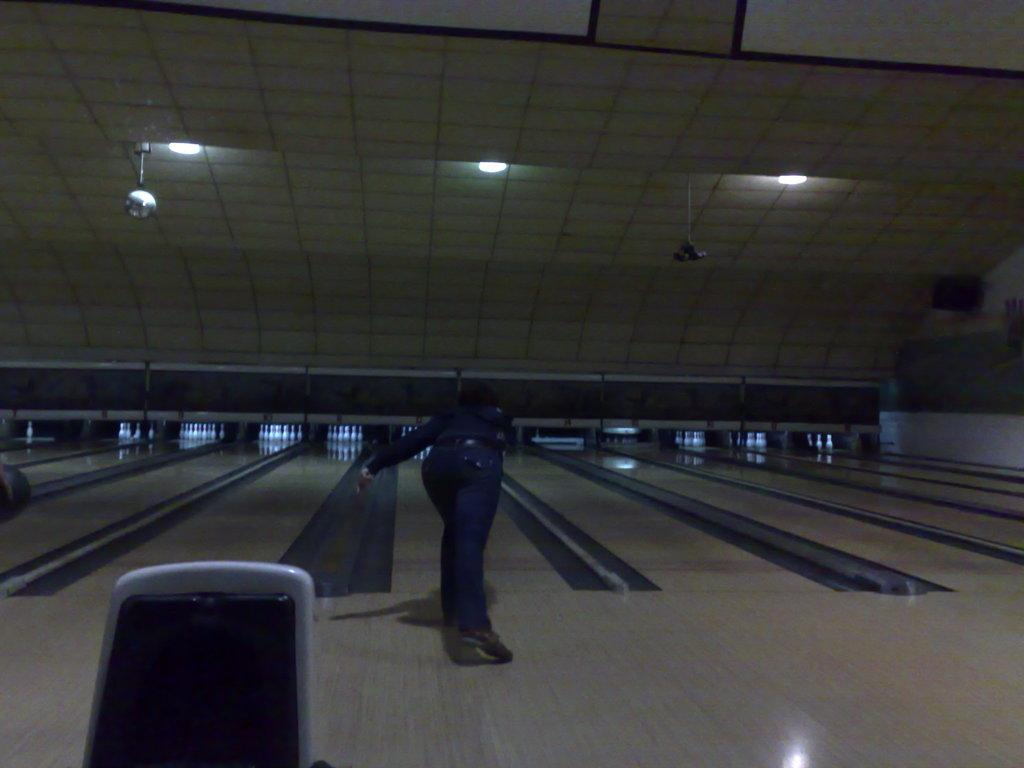What activity is the person in the image engaged in? The person is playing a bowling game. Where is the bowling game taking place? The game is taking place on a floor. What objects are involved in the game? Bowling pins are present in the image. What can be seen in the background or surroundings of the image? There are lights visible in the image. What type of brush is being used to gain knowledge in the image? There is no brush or indication of gaining knowledge present in the image. 